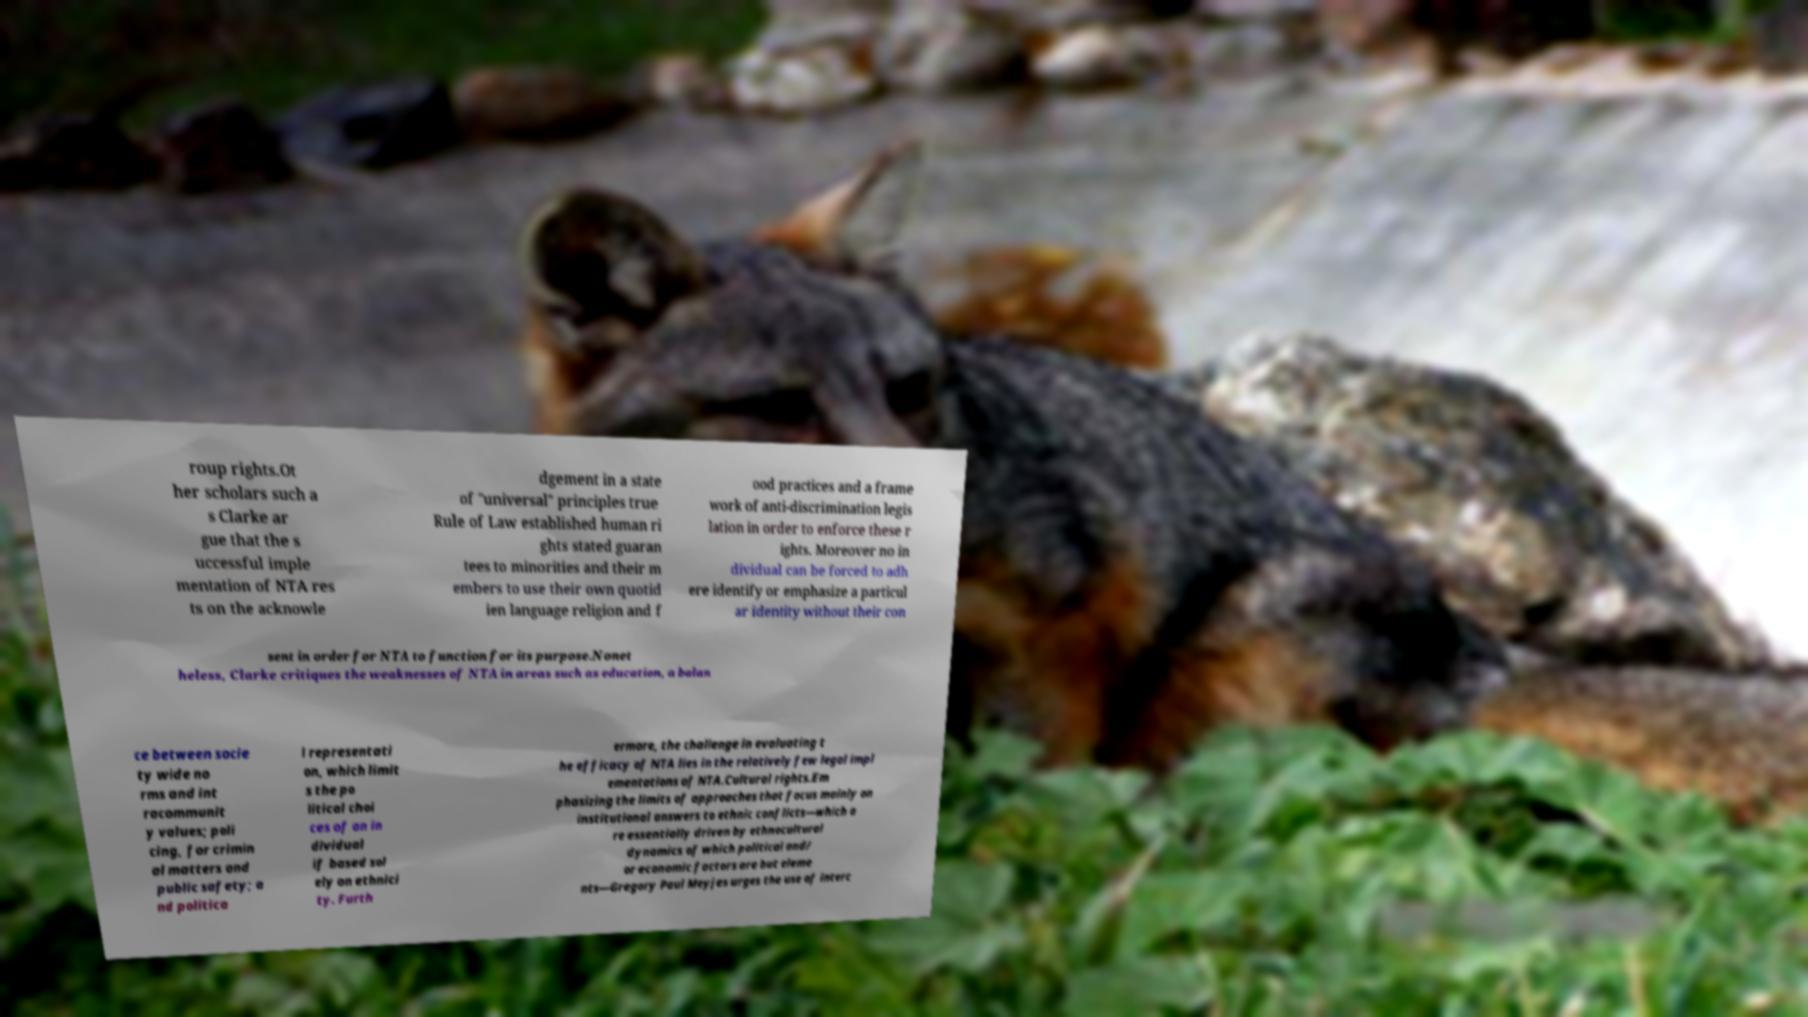For documentation purposes, I need the text within this image transcribed. Could you provide that? roup rights.Ot her scholars such a s Clarke ar gue that the s uccessful imple mentation of NTA res ts on the acknowle dgement in a state of "universal" principles true Rule of Law established human ri ghts stated guaran tees to minorities and their m embers to use their own quotid ien language religion and f ood practices and a frame work of anti-discrimination legis lation in order to enforce these r ights. Moreover no in dividual can be forced to adh ere identify or emphasize a particul ar identity without their con sent in order for NTA to function for its purpose.Nonet heless, Clarke critiques the weaknesses of NTA in areas such as education, a balan ce between socie ty wide no rms and int racommunit y values; poli cing, for crimin al matters and public safety; a nd politica l representati on, which limit s the po litical choi ces of an in dividual if based sol ely on ethnici ty. Furth ermore, the challenge in evaluating t he efficacy of NTA lies in the relatively few legal impl ementations of NTA.Cultural rights.Em phasizing the limits of approaches that focus mainly on institutional answers to ethnic conflicts—which a re essentially driven by ethnocultural dynamics of which political and/ or economic factors are but eleme nts—Gregory Paul Meyjes urges the use of interc 